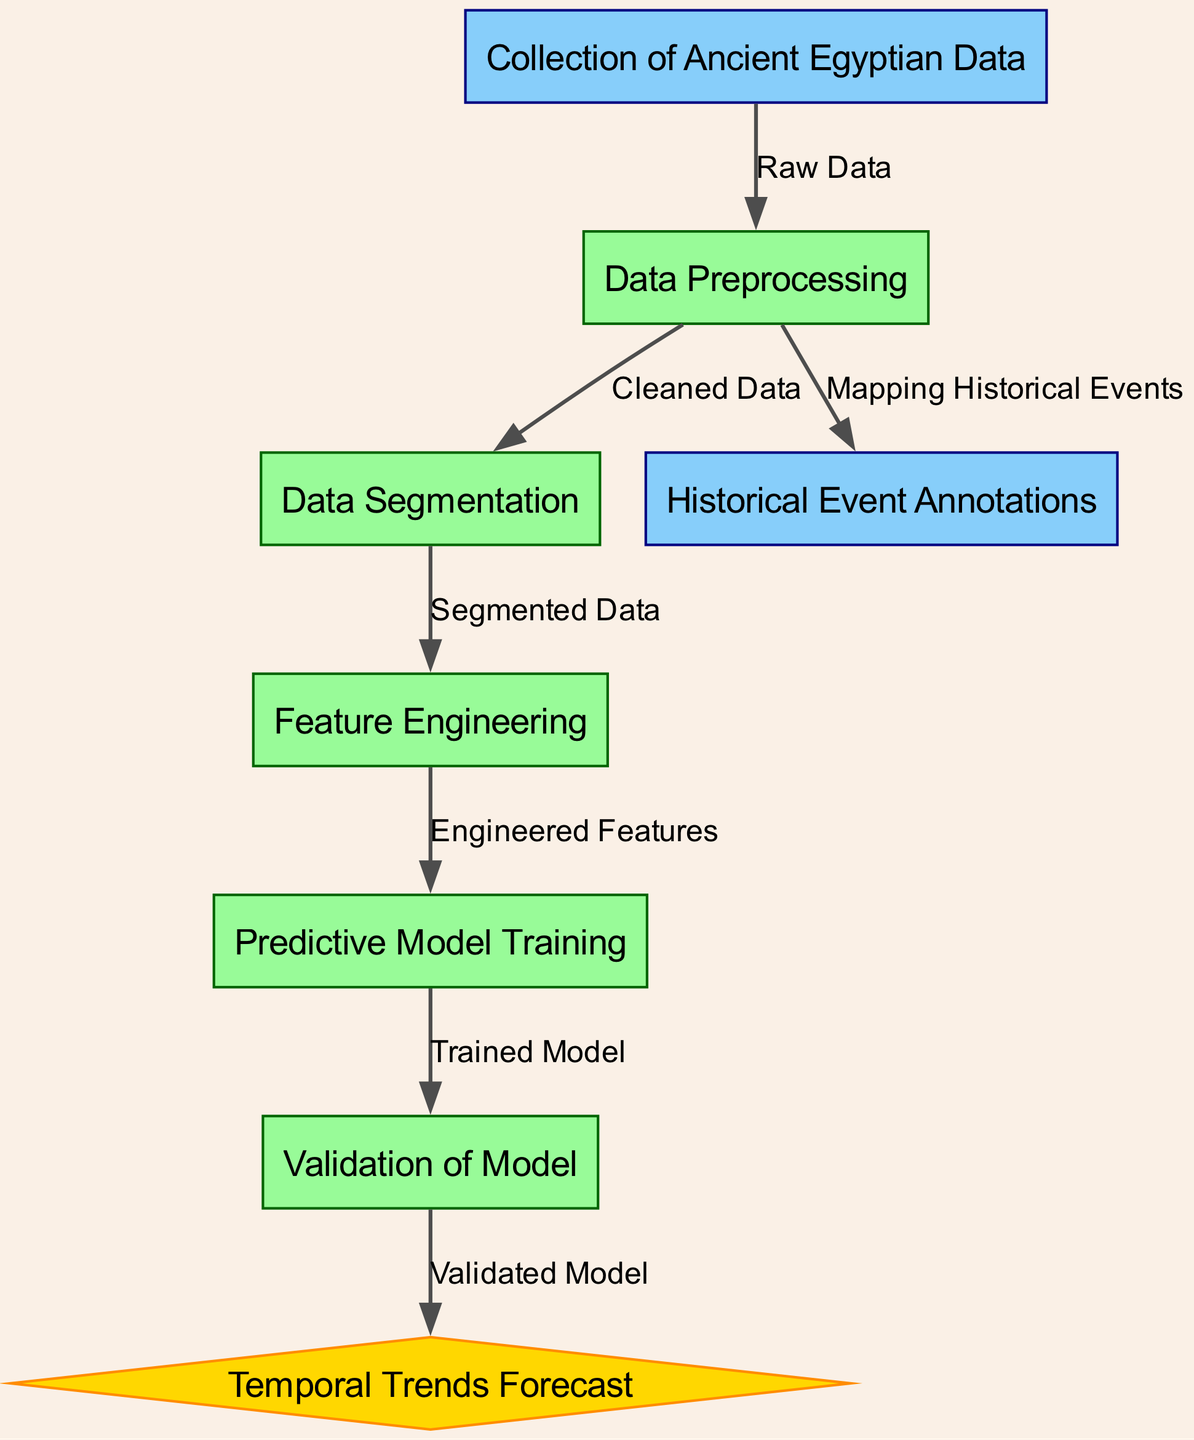What is the first node in the diagram? The first node is labeled "Collection of Ancient Egyptian Data", indicating the initial step of the process.
Answer: Collection of Ancient Egyptian Data How many processes are represented in the diagram? By counting the nodes of type "process", we find there are five such nodes: Data Preprocessing, Data Segmentation, Feature Engineering, Predictive Model Training, and Validation of Model.
Answer: 5 What is the output of the predictive model training? Following the edge relationships, after the predictive model training, the output is the "Trained Model", which is then used for validation.
Answer: Trained Model Which node connects the Data Preprocessing and Historical Event Annotations? The edge identifies that Data Preprocessing is connected directly to Historical Event Annotations, indicating how cleaned data is mapped to historical events.
Answer: Historical Event Annotations What type is the last node in the diagram? The last node is labeled "Temporal Trends Forecast", which is categorized as a result type node, indicated by its distinct diamond shape.
Answer: result What data is mapped during the Data Preprocessing step? The Data Preprocessing step feeds into the Historical Event Annotations, mapping the cleaned data to specific historical events.
Answer: Historical Event Annotations What is the relationship between the nodes "Validation of Model" and "Temporal Trends Forecast"? The relationship shows that the output of the "Validation of Model" feeds into the "Temporal Trends Forecast", suggesting it is derived from a validated model.
Answer: Validated Model What is required prior to predictive model training? The step preceding predictive model training is "Feature Engineering", where features are prepared and finalized before model training.
Answer: Feature Engineering What does the arrow from Data Segmentation lead to? The arrow from Data Segmentation leads to Feature Engineering, implying that after segmenting data, feature engineering is the next essential process.
Answer: Feature Engineering 